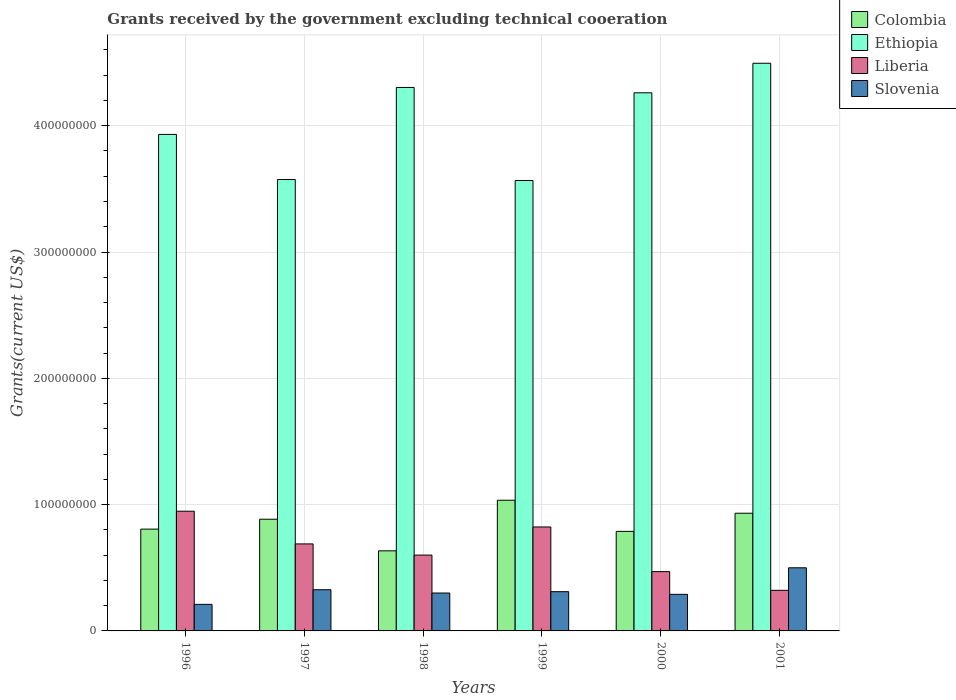How many different coloured bars are there?
Your answer should be compact. 4. How many groups of bars are there?
Your response must be concise. 6. What is the label of the 6th group of bars from the left?
Offer a terse response. 2001. What is the total grants received by the government in Liberia in 1997?
Provide a short and direct response. 6.89e+07. Across all years, what is the maximum total grants received by the government in Colombia?
Your answer should be compact. 1.03e+08. Across all years, what is the minimum total grants received by the government in Liberia?
Keep it short and to the point. 3.21e+07. In which year was the total grants received by the government in Ethiopia maximum?
Make the answer very short. 2001. In which year was the total grants received by the government in Ethiopia minimum?
Offer a very short reply. 1999. What is the total total grants received by the government in Ethiopia in the graph?
Offer a very short reply. 2.41e+09. What is the difference between the total grants received by the government in Colombia in 1996 and that in 2000?
Keep it short and to the point. 1.79e+06. What is the difference between the total grants received by the government in Ethiopia in 1997 and the total grants received by the government in Liberia in 2001?
Your response must be concise. 3.25e+08. What is the average total grants received by the government in Liberia per year?
Provide a short and direct response. 6.42e+07. In the year 1996, what is the difference between the total grants received by the government in Ethiopia and total grants received by the government in Liberia?
Your answer should be very brief. 2.98e+08. In how many years, is the total grants received by the government in Liberia greater than 140000000 US$?
Your answer should be compact. 0. What is the ratio of the total grants received by the government in Colombia in 1996 to that in 1997?
Provide a short and direct response. 0.91. Is the difference between the total grants received by the government in Ethiopia in 1996 and 1997 greater than the difference between the total grants received by the government in Liberia in 1996 and 1997?
Provide a short and direct response. Yes. What is the difference between the highest and the second highest total grants received by the government in Liberia?
Make the answer very short. 1.25e+07. What is the difference between the highest and the lowest total grants received by the government in Colombia?
Offer a terse response. 4.01e+07. In how many years, is the total grants received by the government in Colombia greater than the average total grants received by the government in Colombia taken over all years?
Your answer should be compact. 3. Is the sum of the total grants received by the government in Slovenia in 1997 and 2001 greater than the maximum total grants received by the government in Colombia across all years?
Your response must be concise. No. Is it the case that in every year, the sum of the total grants received by the government in Ethiopia and total grants received by the government in Slovenia is greater than the sum of total grants received by the government in Colombia and total grants received by the government in Liberia?
Keep it short and to the point. Yes. What does the 4th bar from the left in 1999 represents?
Give a very brief answer. Slovenia. Are all the bars in the graph horizontal?
Your response must be concise. No. How many years are there in the graph?
Offer a very short reply. 6. What is the difference between two consecutive major ticks on the Y-axis?
Your answer should be compact. 1.00e+08. Does the graph contain grids?
Give a very brief answer. Yes. Where does the legend appear in the graph?
Keep it short and to the point. Top right. How are the legend labels stacked?
Make the answer very short. Vertical. What is the title of the graph?
Your response must be concise. Grants received by the government excluding technical cooeration. Does "Sweden" appear as one of the legend labels in the graph?
Your response must be concise. No. What is the label or title of the X-axis?
Provide a short and direct response. Years. What is the label or title of the Y-axis?
Offer a terse response. Grants(current US$). What is the Grants(current US$) of Colombia in 1996?
Your answer should be compact. 8.06e+07. What is the Grants(current US$) in Ethiopia in 1996?
Keep it short and to the point. 3.93e+08. What is the Grants(current US$) in Liberia in 1996?
Provide a succinct answer. 9.48e+07. What is the Grants(current US$) in Slovenia in 1996?
Give a very brief answer. 2.10e+07. What is the Grants(current US$) in Colombia in 1997?
Keep it short and to the point. 8.84e+07. What is the Grants(current US$) of Ethiopia in 1997?
Your answer should be compact. 3.57e+08. What is the Grants(current US$) of Liberia in 1997?
Offer a terse response. 6.89e+07. What is the Grants(current US$) of Slovenia in 1997?
Provide a short and direct response. 3.26e+07. What is the Grants(current US$) of Colombia in 1998?
Your response must be concise. 6.34e+07. What is the Grants(current US$) in Ethiopia in 1998?
Offer a very short reply. 4.30e+08. What is the Grants(current US$) of Liberia in 1998?
Your answer should be compact. 6.00e+07. What is the Grants(current US$) in Slovenia in 1998?
Your response must be concise. 3.00e+07. What is the Grants(current US$) of Colombia in 1999?
Give a very brief answer. 1.03e+08. What is the Grants(current US$) in Ethiopia in 1999?
Offer a terse response. 3.57e+08. What is the Grants(current US$) of Liberia in 1999?
Ensure brevity in your answer.  8.23e+07. What is the Grants(current US$) of Slovenia in 1999?
Your answer should be compact. 3.11e+07. What is the Grants(current US$) of Colombia in 2000?
Your response must be concise. 7.88e+07. What is the Grants(current US$) in Ethiopia in 2000?
Your answer should be compact. 4.26e+08. What is the Grants(current US$) in Liberia in 2000?
Ensure brevity in your answer.  4.70e+07. What is the Grants(current US$) in Slovenia in 2000?
Give a very brief answer. 2.90e+07. What is the Grants(current US$) of Colombia in 2001?
Your response must be concise. 9.32e+07. What is the Grants(current US$) of Ethiopia in 2001?
Keep it short and to the point. 4.49e+08. What is the Grants(current US$) in Liberia in 2001?
Provide a short and direct response. 3.21e+07. What is the Grants(current US$) of Slovenia in 2001?
Keep it short and to the point. 5.00e+07. Across all years, what is the maximum Grants(current US$) in Colombia?
Your answer should be compact. 1.03e+08. Across all years, what is the maximum Grants(current US$) of Ethiopia?
Keep it short and to the point. 4.49e+08. Across all years, what is the maximum Grants(current US$) in Liberia?
Give a very brief answer. 9.48e+07. Across all years, what is the maximum Grants(current US$) in Slovenia?
Give a very brief answer. 5.00e+07. Across all years, what is the minimum Grants(current US$) of Colombia?
Offer a very short reply. 6.34e+07. Across all years, what is the minimum Grants(current US$) in Ethiopia?
Offer a very short reply. 3.57e+08. Across all years, what is the minimum Grants(current US$) of Liberia?
Your response must be concise. 3.21e+07. Across all years, what is the minimum Grants(current US$) in Slovenia?
Your response must be concise. 2.10e+07. What is the total Grants(current US$) in Colombia in the graph?
Make the answer very short. 5.08e+08. What is the total Grants(current US$) in Ethiopia in the graph?
Provide a succinct answer. 2.41e+09. What is the total Grants(current US$) of Liberia in the graph?
Ensure brevity in your answer.  3.85e+08. What is the total Grants(current US$) of Slovenia in the graph?
Your answer should be compact. 1.94e+08. What is the difference between the Grants(current US$) in Colombia in 1996 and that in 1997?
Offer a very short reply. -7.82e+06. What is the difference between the Grants(current US$) in Ethiopia in 1996 and that in 1997?
Provide a succinct answer. 3.57e+07. What is the difference between the Grants(current US$) of Liberia in 1996 and that in 1997?
Keep it short and to the point. 2.59e+07. What is the difference between the Grants(current US$) of Slovenia in 1996 and that in 1997?
Ensure brevity in your answer.  -1.16e+07. What is the difference between the Grants(current US$) of Colombia in 1996 and that in 1998?
Your answer should be very brief. 1.72e+07. What is the difference between the Grants(current US$) in Ethiopia in 1996 and that in 1998?
Your answer should be compact. -3.72e+07. What is the difference between the Grants(current US$) in Liberia in 1996 and that in 1998?
Make the answer very short. 3.47e+07. What is the difference between the Grants(current US$) in Slovenia in 1996 and that in 1998?
Offer a terse response. -8.97e+06. What is the difference between the Grants(current US$) of Colombia in 1996 and that in 1999?
Your response must be concise. -2.29e+07. What is the difference between the Grants(current US$) of Ethiopia in 1996 and that in 1999?
Keep it short and to the point. 3.65e+07. What is the difference between the Grants(current US$) of Liberia in 1996 and that in 1999?
Give a very brief answer. 1.25e+07. What is the difference between the Grants(current US$) in Slovenia in 1996 and that in 1999?
Offer a very short reply. -1.00e+07. What is the difference between the Grants(current US$) of Colombia in 1996 and that in 2000?
Ensure brevity in your answer.  1.79e+06. What is the difference between the Grants(current US$) of Ethiopia in 1996 and that in 2000?
Give a very brief answer. -3.29e+07. What is the difference between the Grants(current US$) in Liberia in 1996 and that in 2000?
Your response must be concise. 4.78e+07. What is the difference between the Grants(current US$) in Slovenia in 1996 and that in 2000?
Give a very brief answer. -7.91e+06. What is the difference between the Grants(current US$) of Colombia in 1996 and that in 2001?
Your answer should be very brief. -1.26e+07. What is the difference between the Grants(current US$) of Ethiopia in 1996 and that in 2001?
Your response must be concise. -5.63e+07. What is the difference between the Grants(current US$) in Liberia in 1996 and that in 2001?
Your answer should be compact. 6.26e+07. What is the difference between the Grants(current US$) in Slovenia in 1996 and that in 2001?
Ensure brevity in your answer.  -2.89e+07. What is the difference between the Grants(current US$) of Colombia in 1997 and that in 1998?
Offer a very short reply. 2.50e+07. What is the difference between the Grants(current US$) in Ethiopia in 1997 and that in 1998?
Your response must be concise. -7.29e+07. What is the difference between the Grants(current US$) of Liberia in 1997 and that in 1998?
Ensure brevity in your answer.  8.85e+06. What is the difference between the Grants(current US$) of Slovenia in 1997 and that in 1998?
Provide a succinct answer. 2.61e+06. What is the difference between the Grants(current US$) in Colombia in 1997 and that in 1999?
Offer a very short reply. -1.50e+07. What is the difference between the Grants(current US$) in Ethiopia in 1997 and that in 1999?
Give a very brief answer. 7.90e+05. What is the difference between the Grants(current US$) in Liberia in 1997 and that in 1999?
Provide a succinct answer. -1.34e+07. What is the difference between the Grants(current US$) of Slovenia in 1997 and that in 1999?
Give a very brief answer. 1.55e+06. What is the difference between the Grants(current US$) in Colombia in 1997 and that in 2000?
Keep it short and to the point. 9.61e+06. What is the difference between the Grants(current US$) in Ethiopia in 1997 and that in 2000?
Offer a very short reply. -6.87e+07. What is the difference between the Grants(current US$) in Liberia in 1997 and that in 2000?
Your answer should be very brief. 2.19e+07. What is the difference between the Grants(current US$) of Slovenia in 1997 and that in 2000?
Ensure brevity in your answer.  3.67e+06. What is the difference between the Grants(current US$) in Colombia in 1997 and that in 2001?
Keep it short and to the point. -4.76e+06. What is the difference between the Grants(current US$) in Ethiopia in 1997 and that in 2001?
Your response must be concise. -9.20e+07. What is the difference between the Grants(current US$) of Liberia in 1997 and that in 2001?
Your answer should be very brief. 3.68e+07. What is the difference between the Grants(current US$) of Slovenia in 1997 and that in 2001?
Ensure brevity in your answer.  -1.74e+07. What is the difference between the Grants(current US$) of Colombia in 1998 and that in 1999?
Provide a succinct answer. -4.01e+07. What is the difference between the Grants(current US$) of Ethiopia in 1998 and that in 1999?
Offer a terse response. 7.37e+07. What is the difference between the Grants(current US$) in Liberia in 1998 and that in 1999?
Your answer should be compact. -2.23e+07. What is the difference between the Grants(current US$) in Slovenia in 1998 and that in 1999?
Make the answer very short. -1.06e+06. What is the difference between the Grants(current US$) in Colombia in 1998 and that in 2000?
Offer a very short reply. -1.54e+07. What is the difference between the Grants(current US$) of Ethiopia in 1998 and that in 2000?
Offer a terse response. 4.24e+06. What is the difference between the Grants(current US$) in Liberia in 1998 and that in 2000?
Your answer should be compact. 1.31e+07. What is the difference between the Grants(current US$) in Slovenia in 1998 and that in 2000?
Your answer should be very brief. 1.06e+06. What is the difference between the Grants(current US$) in Colombia in 1998 and that in 2001?
Your answer should be very brief. -2.98e+07. What is the difference between the Grants(current US$) of Ethiopia in 1998 and that in 2001?
Provide a short and direct response. -1.92e+07. What is the difference between the Grants(current US$) in Liberia in 1998 and that in 2001?
Your response must be concise. 2.79e+07. What is the difference between the Grants(current US$) in Slovenia in 1998 and that in 2001?
Keep it short and to the point. -2.00e+07. What is the difference between the Grants(current US$) in Colombia in 1999 and that in 2000?
Offer a terse response. 2.47e+07. What is the difference between the Grants(current US$) in Ethiopia in 1999 and that in 2000?
Provide a short and direct response. -6.94e+07. What is the difference between the Grants(current US$) in Liberia in 1999 and that in 2000?
Your answer should be very brief. 3.54e+07. What is the difference between the Grants(current US$) of Slovenia in 1999 and that in 2000?
Your answer should be very brief. 2.12e+06. What is the difference between the Grants(current US$) in Colombia in 1999 and that in 2001?
Provide a short and direct response. 1.03e+07. What is the difference between the Grants(current US$) in Ethiopia in 1999 and that in 2001?
Give a very brief answer. -9.28e+07. What is the difference between the Grants(current US$) of Liberia in 1999 and that in 2001?
Provide a short and direct response. 5.02e+07. What is the difference between the Grants(current US$) in Slovenia in 1999 and that in 2001?
Your answer should be compact. -1.89e+07. What is the difference between the Grants(current US$) in Colombia in 2000 and that in 2001?
Your answer should be compact. -1.44e+07. What is the difference between the Grants(current US$) in Ethiopia in 2000 and that in 2001?
Your answer should be compact. -2.34e+07. What is the difference between the Grants(current US$) in Liberia in 2000 and that in 2001?
Your answer should be compact. 1.48e+07. What is the difference between the Grants(current US$) in Slovenia in 2000 and that in 2001?
Provide a succinct answer. -2.10e+07. What is the difference between the Grants(current US$) in Colombia in 1996 and the Grants(current US$) in Ethiopia in 1997?
Provide a short and direct response. -2.77e+08. What is the difference between the Grants(current US$) in Colombia in 1996 and the Grants(current US$) in Liberia in 1997?
Offer a terse response. 1.17e+07. What is the difference between the Grants(current US$) in Colombia in 1996 and the Grants(current US$) in Slovenia in 1997?
Your answer should be very brief. 4.80e+07. What is the difference between the Grants(current US$) of Ethiopia in 1996 and the Grants(current US$) of Liberia in 1997?
Offer a terse response. 3.24e+08. What is the difference between the Grants(current US$) in Ethiopia in 1996 and the Grants(current US$) in Slovenia in 1997?
Ensure brevity in your answer.  3.60e+08. What is the difference between the Grants(current US$) of Liberia in 1996 and the Grants(current US$) of Slovenia in 1997?
Keep it short and to the point. 6.22e+07. What is the difference between the Grants(current US$) in Colombia in 1996 and the Grants(current US$) in Ethiopia in 1998?
Keep it short and to the point. -3.50e+08. What is the difference between the Grants(current US$) of Colombia in 1996 and the Grants(current US$) of Liberia in 1998?
Give a very brief answer. 2.06e+07. What is the difference between the Grants(current US$) in Colombia in 1996 and the Grants(current US$) in Slovenia in 1998?
Keep it short and to the point. 5.06e+07. What is the difference between the Grants(current US$) in Ethiopia in 1996 and the Grants(current US$) in Liberia in 1998?
Your answer should be compact. 3.33e+08. What is the difference between the Grants(current US$) of Ethiopia in 1996 and the Grants(current US$) of Slovenia in 1998?
Make the answer very short. 3.63e+08. What is the difference between the Grants(current US$) of Liberia in 1996 and the Grants(current US$) of Slovenia in 1998?
Offer a very short reply. 6.48e+07. What is the difference between the Grants(current US$) in Colombia in 1996 and the Grants(current US$) in Ethiopia in 1999?
Your response must be concise. -2.76e+08. What is the difference between the Grants(current US$) in Colombia in 1996 and the Grants(current US$) in Liberia in 1999?
Your answer should be compact. -1.70e+06. What is the difference between the Grants(current US$) of Colombia in 1996 and the Grants(current US$) of Slovenia in 1999?
Your response must be concise. 4.95e+07. What is the difference between the Grants(current US$) of Ethiopia in 1996 and the Grants(current US$) of Liberia in 1999?
Offer a terse response. 3.11e+08. What is the difference between the Grants(current US$) in Ethiopia in 1996 and the Grants(current US$) in Slovenia in 1999?
Give a very brief answer. 3.62e+08. What is the difference between the Grants(current US$) of Liberia in 1996 and the Grants(current US$) of Slovenia in 1999?
Ensure brevity in your answer.  6.37e+07. What is the difference between the Grants(current US$) of Colombia in 1996 and the Grants(current US$) of Ethiopia in 2000?
Your response must be concise. -3.45e+08. What is the difference between the Grants(current US$) in Colombia in 1996 and the Grants(current US$) in Liberia in 2000?
Make the answer very short. 3.36e+07. What is the difference between the Grants(current US$) of Colombia in 1996 and the Grants(current US$) of Slovenia in 2000?
Offer a terse response. 5.17e+07. What is the difference between the Grants(current US$) of Ethiopia in 1996 and the Grants(current US$) of Liberia in 2000?
Ensure brevity in your answer.  3.46e+08. What is the difference between the Grants(current US$) in Ethiopia in 1996 and the Grants(current US$) in Slovenia in 2000?
Keep it short and to the point. 3.64e+08. What is the difference between the Grants(current US$) of Liberia in 1996 and the Grants(current US$) of Slovenia in 2000?
Offer a terse response. 6.58e+07. What is the difference between the Grants(current US$) of Colombia in 1996 and the Grants(current US$) of Ethiopia in 2001?
Your response must be concise. -3.69e+08. What is the difference between the Grants(current US$) of Colombia in 1996 and the Grants(current US$) of Liberia in 2001?
Ensure brevity in your answer.  4.85e+07. What is the difference between the Grants(current US$) in Colombia in 1996 and the Grants(current US$) in Slovenia in 2001?
Offer a very short reply. 3.06e+07. What is the difference between the Grants(current US$) in Ethiopia in 1996 and the Grants(current US$) in Liberia in 2001?
Make the answer very short. 3.61e+08. What is the difference between the Grants(current US$) in Ethiopia in 1996 and the Grants(current US$) in Slovenia in 2001?
Offer a very short reply. 3.43e+08. What is the difference between the Grants(current US$) in Liberia in 1996 and the Grants(current US$) in Slovenia in 2001?
Your response must be concise. 4.48e+07. What is the difference between the Grants(current US$) of Colombia in 1997 and the Grants(current US$) of Ethiopia in 1998?
Provide a succinct answer. -3.42e+08. What is the difference between the Grants(current US$) of Colombia in 1997 and the Grants(current US$) of Liberia in 1998?
Your answer should be very brief. 2.84e+07. What is the difference between the Grants(current US$) of Colombia in 1997 and the Grants(current US$) of Slovenia in 1998?
Provide a succinct answer. 5.84e+07. What is the difference between the Grants(current US$) of Ethiopia in 1997 and the Grants(current US$) of Liberia in 1998?
Provide a short and direct response. 2.97e+08. What is the difference between the Grants(current US$) of Ethiopia in 1997 and the Grants(current US$) of Slovenia in 1998?
Your answer should be very brief. 3.27e+08. What is the difference between the Grants(current US$) in Liberia in 1997 and the Grants(current US$) in Slovenia in 1998?
Provide a short and direct response. 3.89e+07. What is the difference between the Grants(current US$) in Colombia in 1997 and the Grants(current US$) in Ethiopia in 1999?
Your answer should be very brief. -2.68e+08. What is the difference between the Grants(current US$) in Colombia in 1997 and the Grants(current US$) in Liberia in 1999?
Your response must be concise. 6.12e+06. What is the difference between the Grants(current US$) of Colombia in 1997 and the Grants(current US$) of Slovenia in 1999?
Give a very brief answer. 5.74e+07. What is the difference between the Grants(current US$) of Ethiopia in 1997 and the Grants(current US$) of Liberia in 1999?
Offer a very short reply. 2.75e+08. What is the difference between the Grants(current US$) of Ethiopia in 1997 and the Grants(current US$) of Slovenia in 1999?
Your answer should be compact. 3.26e+08. What is the difference between the Grants(current US$) in Liberia in 1997 and the Grants(current US$) in Slovenia in 1999?
Keep it short and to the point. 3.78e+07. What is the difference between the Grants(current US$) in Colombia in 1997 and the Grants(current US$) in Ethiopia in 2000?
Ensure brevity in your answer.  -3.38e+08. What is the difference between the Grants(current US$) in Colombia in 1997 and the Grants(current US$) in Liberia in 2000?
Provide a short and direct response. 4.15e+07. What is the difference between the Grants(current US$) in Colombia in 1997 and the Grants(current US$) in Slovenia in 2000?
Your response must be concise. 5.95e+07. What is the difference between the Grants(current US$) of Ethiopia in 1997 and the Grants(current US$) of Liberia in 2000?
Keep it short and to the point. 3.10e+08. What is the difference between the Grants(current US$) of Ethiopia in 1997 and the Grants(current US$) of Slovenia in 2000?
Provide a short and direct response. 3.28e+08. What is the difference between the Grants(current US$) of Liberia in 1997 and the Grants(current US$) of Slovenia in 2000?
Offer a terse response. 3.99e+07. What is the difference between the Grants(current US$) of Colombia in 1997 and the Grants(current US$) of Ethiopia in 2001?
Your answer should be very brief. -3.61e+08. What is the difference between the Grants(current US$) in Colombia in 1997 and the Grants(current US$) in Liberia in 2001?
Keep it short and to the point. 5.63e+07. What is the difference between the Grants(current US$) of Colombia in 1997 and the Grants(current US$) of Slovenia in 2001?
Give a very brief answer. 3.84e+07. What is the difference between the Grants(current US$) in Ethiopia in 1997 and the Grants(current US$) in Liberia in 2001?
Provide a succinct answer. 3.25e+08. What is the difference between the Grants(current US$) in Ethiopia in 1997 and the Grants(current US$) in Slovenia in 2001?
Provide a succinct answer. 3.07e+08. What is the difference between the Grants(current US$) in Liberia in 1997 and the Grants(current US$) in Slovenia in 2001?
Make the answer very short. 1.89e+07. What is the difference between the Grants(current US$) in Colombia in 1998 and the Grants(current US$) in Ethiopia in 1999?
Offer a very short reply. -2.93e+08. What is the difference between the Grants(current US$) in Colombia in 1998 and the Grants(current US$) in Liberia in 1999?
Your answer should be compact. -1.89e+07. What is the difference between the Grants(current US$) in Colombia in 1998 and the Grants(current US$) in Slovenia in 1999?
Provide a succinct answer. 3.23e+07. What is the difference between the Grants(current US$) in Ethiopia in 1998 and the Grants(current US$) in Liberia in 1999?
Offer a very short reply. 3.48e+08. What is the difference between the Grants(current US$) in Ethiopia in 1998 and the Grants(current US$) in Slovenia in 1999?
Your answer should be compact. 3.99e+08. What is the difference between the Grants(current US$) of Liberia in 1998 and the Grants(current US$) of Slovenia in 1999?
Your answer should be very brief. 2.90e+07. What is the difference between the Grants(current US$) in Colombia in 1998 and the Grants(current US$) in Ethiopia in 2000?
Your response must be concise. -3.63e+08. What is the difference between the Grants(current US$) in Colombia in 1998 and the Grants(current US$) in Liberia in 2000?
Your answer should be very brief. 1.64e+07. What is the difference between the Grants(current US$) in Colombia in 1998 and the Grants(current US$) in Slovenia in 2000?
Ensure brevity in your answer.  3.45e+07. What is the difference between the Grants(current US$) in Ethiopia in 1998 and the Grants(current US$) in Liberia in 2000?
Offer a very short reply. 3.83e+08. What is the difference between the Grants(current US$) in Ethiopia in 1998 and the Grants(current US$) in Slovenia in 2000?
Offer a terse response. 4.01e+08. What is the difference between the Grants(current US$) of Liberia in 1998 and the Grants(current US$) of Slovenia in 2000?
Your answer should be very brief. 3.11e+07. What is the difference between the Grants(current US$) of Colombia in 1998 and the Grants(current US$) of Ethiopia in 2001?
Offer a terse response. -3.86e+08. What is the difference between the Grants(current US$) of Colombia in 1998 and the Grants(current US$) of Liberia in 2001?
Your answer should be very brief. 3.13e+07. What is the difference between the Grants(current US$) of Colombia in 1998 and the Grants(current US$) of Slovenia in 2001?
Offer a very short reply. 1.34e+07. What is the difference between the Grants(current US$) of Ethiopia in 1998 and the Grants(current US$) of Liberia in 2001?
Ensure brevity in your answer.  3.98e+08. What is the difference between the Grants(current US$) in Ethiopia in 1998 and the Grants(current US$) in Slovenia in 2001?
Offer a terse response. 3.80e+08. What is the difference between the Grants(current US$) of Liberia in 1998 and the Grants(current US$) of Slovenia in 2001?
Ensure brevity in your answer.  1.01e+07. What is the difference between the Grants(current US$) of Colombia in 1999 and the Grants(current US$) of Ethiopia in 2000?
Provide a succinct answer. -3.23e+08. What is the difference between the Grants(current US$) of Colombia in 1999 and the Grants(current US$) of Liberia in 2000?
Your response must be concise. 5.65e+07. What is the difference between the Grants(current US$) of Colombia in 1999 and the Grants(current US$) of Slovenia in 2000?
Provide a short and direct response. 7.45e+07. What is the difference between the Grants(current US$) of Ethiopia in 1999 and the Grants(current US$) of Liberia in 2000?
Ensure brevity in your answer.  3.10e+08. What is the difference between the Grants(current US$) of Ethiopia in 1999 and the Grants(current US$) of Slovenia in 2000?
Your response must be concise. 3.28e+08. What is the difference between the Grants(current US$) in Liberia in 1999 and the Grants(current US$) in Slovenia in 2000?
Keep it short and to the point. 5.34e+07. What is the difference between the Grants(current US$) of Colombia in 1999 and the Grants(current US$) of Ethiopia in 2001?
Your answer should be compact. -3.46e+08. What is the difference between the Grants(current US$) of Colombia in 1999 and the Grants(current US$) of Liberia in 2001?
Provide a succinct answer. 7.14e+07. What is the difference between the Grants(current US$) in Colombia in 1999 and the Grants(current US$) in Slovenia in 2001?
Offer a terse response. 5.35e+07. What is the difference between the Grants(current US$) in Ethiopia in 1999 and the Grants(current US$) in Liberia in 2001?
Your response must be concise. 3.24e+08. What is the difference between the Grants(current US$) of Ethiopia in 1999 and the Grants(current US$) of Slovenia in 2001?
Provide a short and direct response. 3.07e+08. What is the difference between the Grants(current US$) in Liberia in 1999 and the Grants(current US$) in Slovenia in 2001?
Make the answer very short. 3.23e+07. What is the difference between the Grants(current US$) of Colombia in 2000 and the Grants(current US$) of Ethiopia in 2001?
Give a very brief answer. -3.71e+08. What is the difference between the Grants(current US$) of Colombia in 2000 and the Grants(current US$) of Liberia in 2001?
Offer a very short reply. 4.67e+07. What is the difference between the Grants(current US$) in Colombia in 2000 and the Grants(current US$) in Slovenia in 2001?
Ensure brevity in your answer.  2.88e+07. What is the difference between the Grants(current US$) of Ethiopia in 2000 and the Grants(current US$) of Liberia in 2001?
Your answer should be compact. 3.94e+08. What is the difference between the Grants(current US$) of Ethiopia in 2000 and the Grants(current US$) of Slovenia in 2001?
Give a very brief answer. 3.76e+08. What is the difference between the Grants(current US$) of Liberia in 2000 and the Grants(current US$) of Slovenia in 2001?
Your response must be concise. -3.02e+06. What is the average Grants(current US$) of Colombia per year?
Your answer should be compact. 8.47e+07. What is the average Grants(current US$) in Ethiopia per year?
Your response must be concise. 4.02e+08. What is the average Grants(current US$) of Liberia per year?
Give a very brief answer. 6.42e+07. What is the average Grants(current US$) in Slovenia per year?
Make the answer very short. 3.23e+07. In the year 1996, what is the difference between the Grants(current US$) of Colombia and Grants(current US$) of Ethiopia?
Your answer should be very brief. -3.13e+08. In the year 1996, what is the difference between the Grants(current US$) in Colombia and Grants(current US$) in Liberia?
Your answer should be compact. -1.42e+07. In the year 1996, what is the difference between the Grants(current US$) of Colombia and Grants(current US$) of Slovenia?
Offer a very short reply. 5.96e+07. In the year 1996, what is the difference between the Grants(current US$) of Ethiopia and Grants(current US$) of Liberia?
Offer a terse response. 2.98e+08. In the year 1996, what is the difference between the Grants(current US$) of Ethiopia and Grants(current US$) of Slovenia?
Make the answer very short. 3.72e+08. In the year 1996, what is the difference between the Grants(current US$) of Liberia and Grants(current US$) of Slovenia?
Offer a very short reply. 7.37e+07. In the year 1997, what is the difference between the Grants(current US$) in Colombia and Grants(current US$) in Ethiopia?
Offer a very short reply. -2.69e+08. In the year 1997, what is the difference between the Grants(current US$) of Colombia and Grants(current US$) of Liberia?
Your answer should be compact. 1.95e+07. In the year 1997, what is the difference between the Grants(current US$) of Colombia and Grants(current US$) of Slovenia?
Your answer should be compact. 5.58e+07. In the year 1997, what is the difference between the Grants(current US$) in Ethiopia and Grants(current US$) in Liberia?
Offer a very short reply. 2.89e+08. In the year 1997, what is the difference between the Grants(current US$) of Ethiopia and Grants(current US$) of Slovenia?
Your answer should be compact. 3.25e+08. In the year 1997, what is the difference between the Grants(current US$) of Liberia and Grants(current US$) of Slovenia?
Provide a short and direct response. 3.63e+07. In the year 1998, what is the difference between the Grants(current US$) in Colombia and Grants(current US$) in Ethiopia?
Your answer should be compact. -3.67e+08. In the year 1998, what is the difference between the Grants(current US$) of Colombia and Grants(current US$) of Liberia?
Your response must be concise. 3.37e+06. In the year 1998, what is the difference between the Grants(current US$) in Colombia and Grants(current US$) in Slovenia?
Provide a short and direct response. 3.34e+07. In the year 1998, what is the difference between the Grants(current US$) in Ethiopia and Grants(current US$) in Liberia?
Make the answer very short. 3.70e+08. In the year 1998, what is the difference between the Grants(current US$) of Ethiopia and Grants(current US$) of Slovenia?
Keep it short and to the point. 4.00e+08. In the year 1998, what is the difference between the Grants(current US$) of Liberia and Grants(current US$) of Slovenia?
Provide a short and direct response. 3.00e+07. In the year 1999, what is the difference between the Grants(current US$) of Colombia and Grants(current US$) of Ethiopia?
Ensure brevity in your answer.  -2.53e+08. In the year 1999, what is the difference between the Grants(current US$) in Colombia and Grants(current US$) in Liberia?
Offer a terse response. 2.12e+07. In the year 1999, what is the difference between the Grants(current US$) in Colombia and Grants(current US$) in Slovenia?
Provide a succinct answer. 7.24e+07. In the year 1999, what is the difference between the Grants(current US$) in Ethiopia and Grants(current US$) in Liberia?
Your answer should be compact. 2.74e+08. In the year 1999, what is the difference between the Grants(current US$) in Ethiopia and Grants(current US$) in Slovenia?
Ensure brevity in your answer.  3.26e+08. In the year 1999, what is the difference between the Grants(current US$) of Liberia and Grants(current US$) of Slovenia?
Your answer should be very brief. 5.12e+07. In the year 2000, what is the difference between the Grants(current US$) in Colombia and Grants(current US$) in Ethiopia?
Make the answer very short. -3.47e+08. In the year 2000, what is the difference between the Grants(current US$) of Colombia and Grants(current US$) of Liberia?
Give a very brief answer. 3.19e+07. In the year 2000, what is the difference between the Grants(current US$) in Colombia and Grants(current US$) in Slovenia?
Give a very brief answer. 4.99e+07. In the year 2000, what is the difference between the Grants(current US$) in Ethiopia and Grants(current US$) in Liberia?
Keep it short and to the point. 3.79e+08. In the year 2000, what is the difference between the Grants(current US$) in Ethiopia and Grants(current US$) in Slovenia?
Offer a very short reply. 3.97e+08. In the year 2000, what is the difference between the Grants(current US$) of Liberia and Grants(current US$) of Slovenia?
Make the answer very short. 1.80e+07. In the year 2001, what is the difference between the Grants(current US$) in Colombia and Grants(current US$) in Ethiopia?
Provide a short and direct response. -3.56e+08. In the year 2001, what is the difference between the Grants(current US$) in Colombia and Grants(current US$) in Liberia?
Provide a succinct answer. 6.11e+07. In the year 2001, what is the difference between the Grants(current US$) of Colombia and Grants(current US$) of Slovenia?
Ensure brevity in your answer.  4.32e+07. In the year 2001, what is the difference between the Grants(current US$) of Ethiopia and Grants(current US$) of Liberia?
Your response must be concise. 4.17e+08. In the year 2001, what is the difference between the Grants(current US$) in Ethiopia and Grants(current US$) in Slovenia?
Your answer should be very brief. 3.99e+08. In the year 2001, what is the difference between the Grants(current US$) in Liberia and Grants(current US$) in Slovenia?
Make the answer very short. -1.78e+07. What is the ratio of the Grants(current US$) of Colombia in 1996 to that in 1997?
Your answer should be compact. 0.91. What is the ratio of the Grants(current US$) in Ethiopia in 1996 to that in 1997?
Offer a very short reply. 1.1. What is the ratio of the Grants(current US$) of Liberia in 1996 to that in 1997?
Keep it short and to the point. 1.38. What is the ratio of the Grants(current US$) of Slovenia in 1996 to that in 1997?
Your answer should be compact. 0.65. What is the ratio of the Grants(current US$) of Colombia in 1996 to that in 1998?
Keep it short and to the point. 1.27. What is the ratio of the Grants(current US$) in Ethiopia in 1996 to that in 1998?
Offer a terse response. 0.91. What is the ratio of the Grants(current US$) in Liberia in 1996 to that in 1998?
Keep it short and to the point. 1.58. What is the ratio of the Grants(current US$) of Slovenia in 1996 to that in 1998?
Provide a succinct answer. 0.7. What is the ratio of the Grants(current US$) of Colombia in 1996 to that in 1999?
Make the answer very short. 0.78. What is the ratio of the Grants(current US$) of Ethiopia in 1996 to that in 1999?
Make the answer very short. 1.1. What is the ratio of the Grants(current US$) of Liberia in 1996 to that in 1999?
Make the answer very short. 1.15. What is the ratio of the Grants(current US$) in Slovenia in 1996 to that in 1999?
Your response must be concise. 0.68. What is the ratio of the Grants(current US$) of Colombia in 1996 to that in 2000?
Ensure brevity in your answer.  1.02. What is the ratio of the Grants(current US$) of Ethiopia in 1996 to that in 2000?
Give a very brief answer. 0.92. What is the ratio of the Grants(current US$) in Liberia in 1996 to that in 2000?
Keep it short and to the point. 2.02. What is the ratio of the Grants(current US$) of Slovenia in 1996 to that in 2000?
Provide a short and direct response. 0.73. What is the ratio of the Grants(current US$) of Colombia in 1996 to that in 2001?
Keep it short and to the point. 0.86. What is the ratio of the Grants(current US$) of Ethiopia in 1996 to that in 2001?
Provide a short and direct response. 0.87. What is the ratio of the Grants(current US$) of Liberia in 1996 to that in 2001?
Offer a terse response. 2.95. What is the ratio of the Grants(current US$) of Slovenia in 1996 to that in 2001?
Offer a very short reply. 0.42. What is the ratio of the Grants(current US$) of Colombia in 1997 to that in 1998?
Give a very brief answer. 1.39. What is the ratio of the Grants(current US$) in Ethiopia in 1997 to that in 1998?
Your response must be concise. 0.83. What is the ratio of the Grants(current US$) of Liberia in 1997 to that in 1998?
Offer a very short reply. 1.15. What is the ratio of the Grants(current US$) of Slovenia in 1997 to that in 1998?
Ensure brevity in your answer.  1.09. What is the ratio of the Grants(current US$) of Colombia in 1997 to that in 1999?
Provide a succinct answer. 0.85. What is the ratio of the Grants(current US$) of Ethiopia in 1997 to that in 1999?
Your answer should be very brief. 1. What is the ratio of the Grants(current US$) of Liberia in 1997 to that in 1999?
Your response must be concise. 0.84. What is the ratio of the Grants(current US$) in Slovenia in 1997 to that in 1999?
Give a very brief answer. 1.05. What is the ratio of the Grants(current US$) of Colombia in 1997 to that in 2000?
Offer a terse response. 1.12. What is the ratio of the Grants(current US$) in Ethiopia in 1997 to that in 2000?
Offer a very short reply. 0.84. What is the ratio of the Grants(current US$) in Liberia in 1997 to that in 2000?
Your response must be concise. 1.47. What is the ratio of the Grants(current US$) in Slovenia in 1997 to that in 2000?
Offer a very short reply. 1.13. What is the ratio of the Grants(current US$) of Colombia in 1997 to that in 2001?
Make the answer very short. 0.95. What is the ratio of the Grants(current US$) in Ethiopia in 1997 to that in 2001?
Offer a very short reply. 0.8. What is the ratio of the Grants(current US$) of Liberia in 1997 to that in 2001?
Provide a short and direct response. 2.14. What is the ratio of the Grants(current US$) of Slovenia in 1997 to that in 2001?
Give a very brief answer. 0.65. What is the ratio of the Grants(current US$) of Colombia in 1998 to that in 1999?
Offer a very short reply. 0.61. What is the ratio of the Grants(current US$) of Ethiopia in 1998 to that in 1999?
Provide a short and direct response. 1.21. What is the ratio of the Grants(current US$) in Liberia in 1998 to that in 1999?
Your answer should be compact. 0.73. What is the ratio of the Grants(current US$) in Slovenia in 1998 to that in 1999?
Your answer should be compact. 0.97. What is the ratio of the Grants(current US$) of Colombia in 1998 to that in 2000?
Give a very brief answer. 0.8. What is the ratio of the Grants(current US$) of Ethiopia in 1998 to that in 2000?
Ensure brevity in your answer.  1.01. What is the ratio of the Grants(current US$) of Liberia in 1998 to that in 2000?
Your answer should be compact. 1.28. What is the ratio of the Grants(current US$) in Slovenia in 1998 to that in 2000?
Offer a terse response. 1.04. What is the ratio of the Grants(current US$) of Colombia in 1998 to that in 2001?
Ensure brevity in your answer.  0.68. What is the ratio of the Grants(current US$) in Ethiopia in 1998 to that in 2001?
Make the answer very short. 0.96. What is the ratio of the Grants(current US$) in Liberia in 1998 to that in 2001?
Provide a succinct answer. 1.87. What is the ratio of the Grants(current US$) of Slovenia in 1998 to that in 2001?
Provide a succinct answer. 0.6. What is the ratio of the Grants(current US$) in Colombia in 1999 to that in 2000?
Make the answer very short. 1.31. What is the ratio of the Grants(current US$) in Ethiopia in 1999 to that in 2000?
Ensure brevity in your answer.  0.84. What is the ratio of the Grants(current US$) in Liberia in 1999 to that in 2000?
Ensure brevity in your answer.  1.75. What is the ratio of the Grants(current US$) in Slovenia in 1999 to that in 2000?
Keep it short and to the point. 1.07. What is the ratio of the Grants(current US$) of Colombia in 1999 to that in 2001?
Give a very brief answer. 1.11. What is the ratio of the Grants(current US$) of Ethiopia in 1999 to that in 2001?
Your answer should be compact. 0.79. What is the ratio of the Grants(current US$) in Liberia in 1999 to that in 2001?
Ensure brevity in your answer.  2.56. What is the ratio of the Grants(current US$) in Slovenia in 1999 to that in 2001?
Offer a terse response. 0.62. What is the ratio of the Grants(current US$) of Colombia in 2000 to that in 2001?
Give a very brief answer. 0.85. What is the ratio of the Grants(current US$) of Ethiopia in 2000 to that in 2001?
Your answer should be very brief. 0.95. What is the ratio of the Grants(current US$) in Liberia in 2000 to that in 2001?
Your response must be concise. 1.46. What is the ratio of the Grants(current US$) in Slovenia in 2000 to that in 2001?
Give a very brief answer. 0.58. What is the difference between the highest and the second highest Grants(current US$) of Colombia?
Offer a terse response. 1.03e+07. What is the difference between the highest and the second highest Grants(current US$) in Ethiopia?
Your answer should be compact. 1.92e+07. What is the difference between the highest and the second highest Grants(current US$) of Liberia?
Your response must be concise. 1.25e+07. What is the difference between the highest and the second highest Grants(current US$) in Slovenia?
Offer a terse response. 1.74e+07. What is the difference between the highest and the lowest Grants(current US$) of Colombia?
Offer a very short reply. 4.01e+07. What is the difference between the highest and the lowest Grants(current US$) of Ethiopia?
Your answer should be compact. 9.28e+07. What is the difference between the highest and the lowest Grants(current US$) in Liberia?
Offer a very short reply. 6.26e+07. What is the difference between the highest and the lowest Grants(current US$) of Slovenia?
Your answer should be compact. 2.89e+07. 